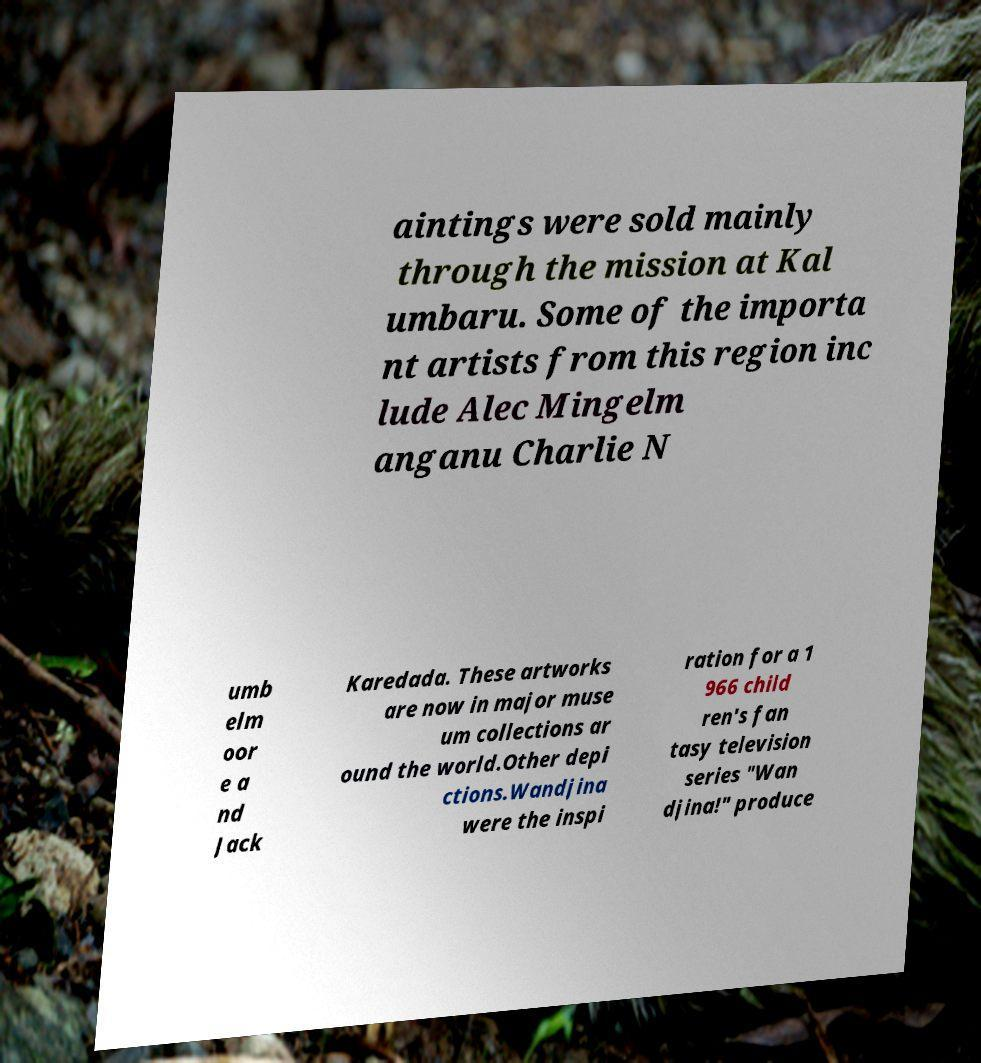There's text embedded in this image that I need extracted. Can you transcribe it verbatim? aintings were sold mainly through the mission at Kal umbaru. Some of the importa nt artists from this region inc lude Alec Mingelm anganu Charlie N umb elm oor e a nd Jack Karedada. These artworks are now in major muse um collections ar ound the world.Other depi ctions.Wandjina were the inspi ration for a 1 966 child ren's fan tasy television series "Wan djina!" produce 